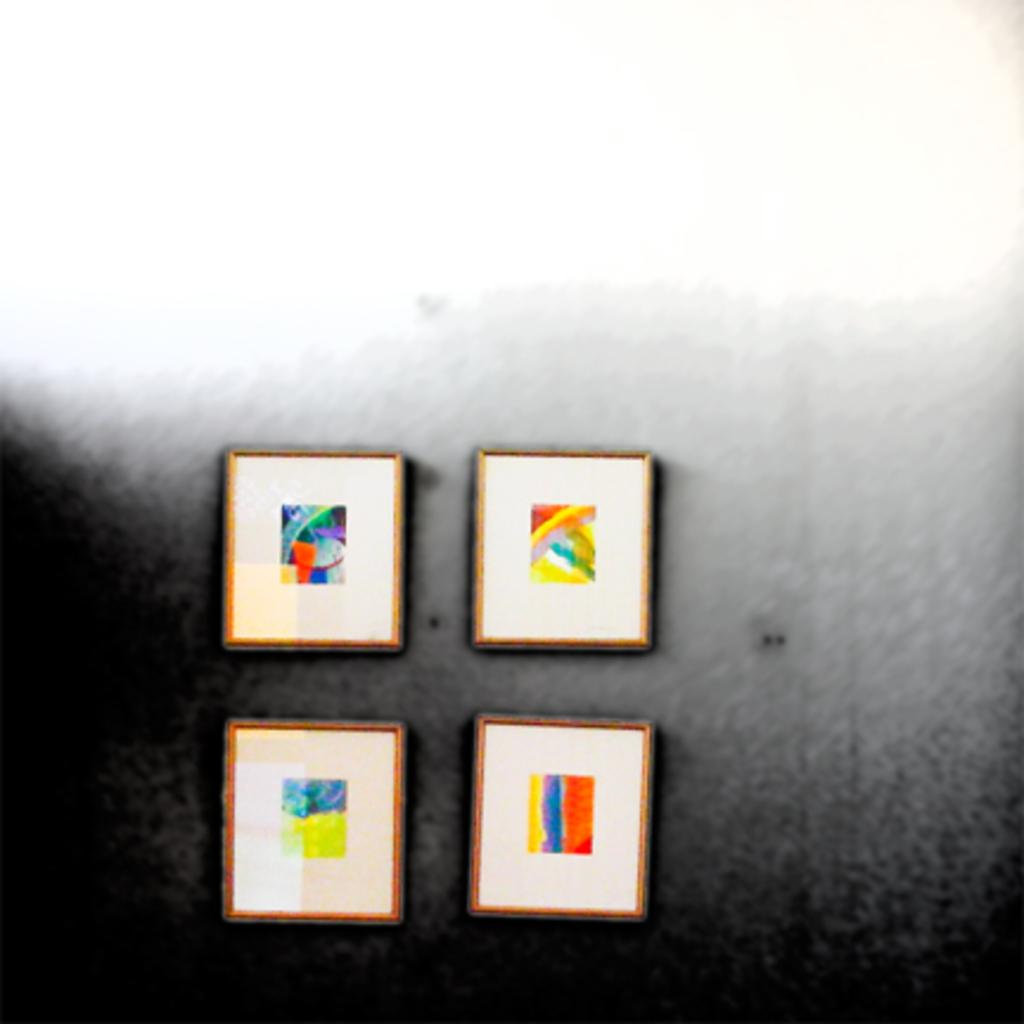What can be inferred about the nature of the image? The image appears to be an edited picture. What is located in the middle of the image? There are frames in the middle of the image. What color is the surface visible in the image? The surface in the image is grey. How many visitors can be seen sitting at the desk in the image? There is no desk or visitors present in the image. What type of bat is flying in the image? There is no bat present in the image. 